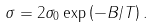<formula> <loc_0><loc_0><loc_500><loc_500>\sigma = 2 \sigma _ { 0 } \exp \left ( - B / T \right ) .</formula> 